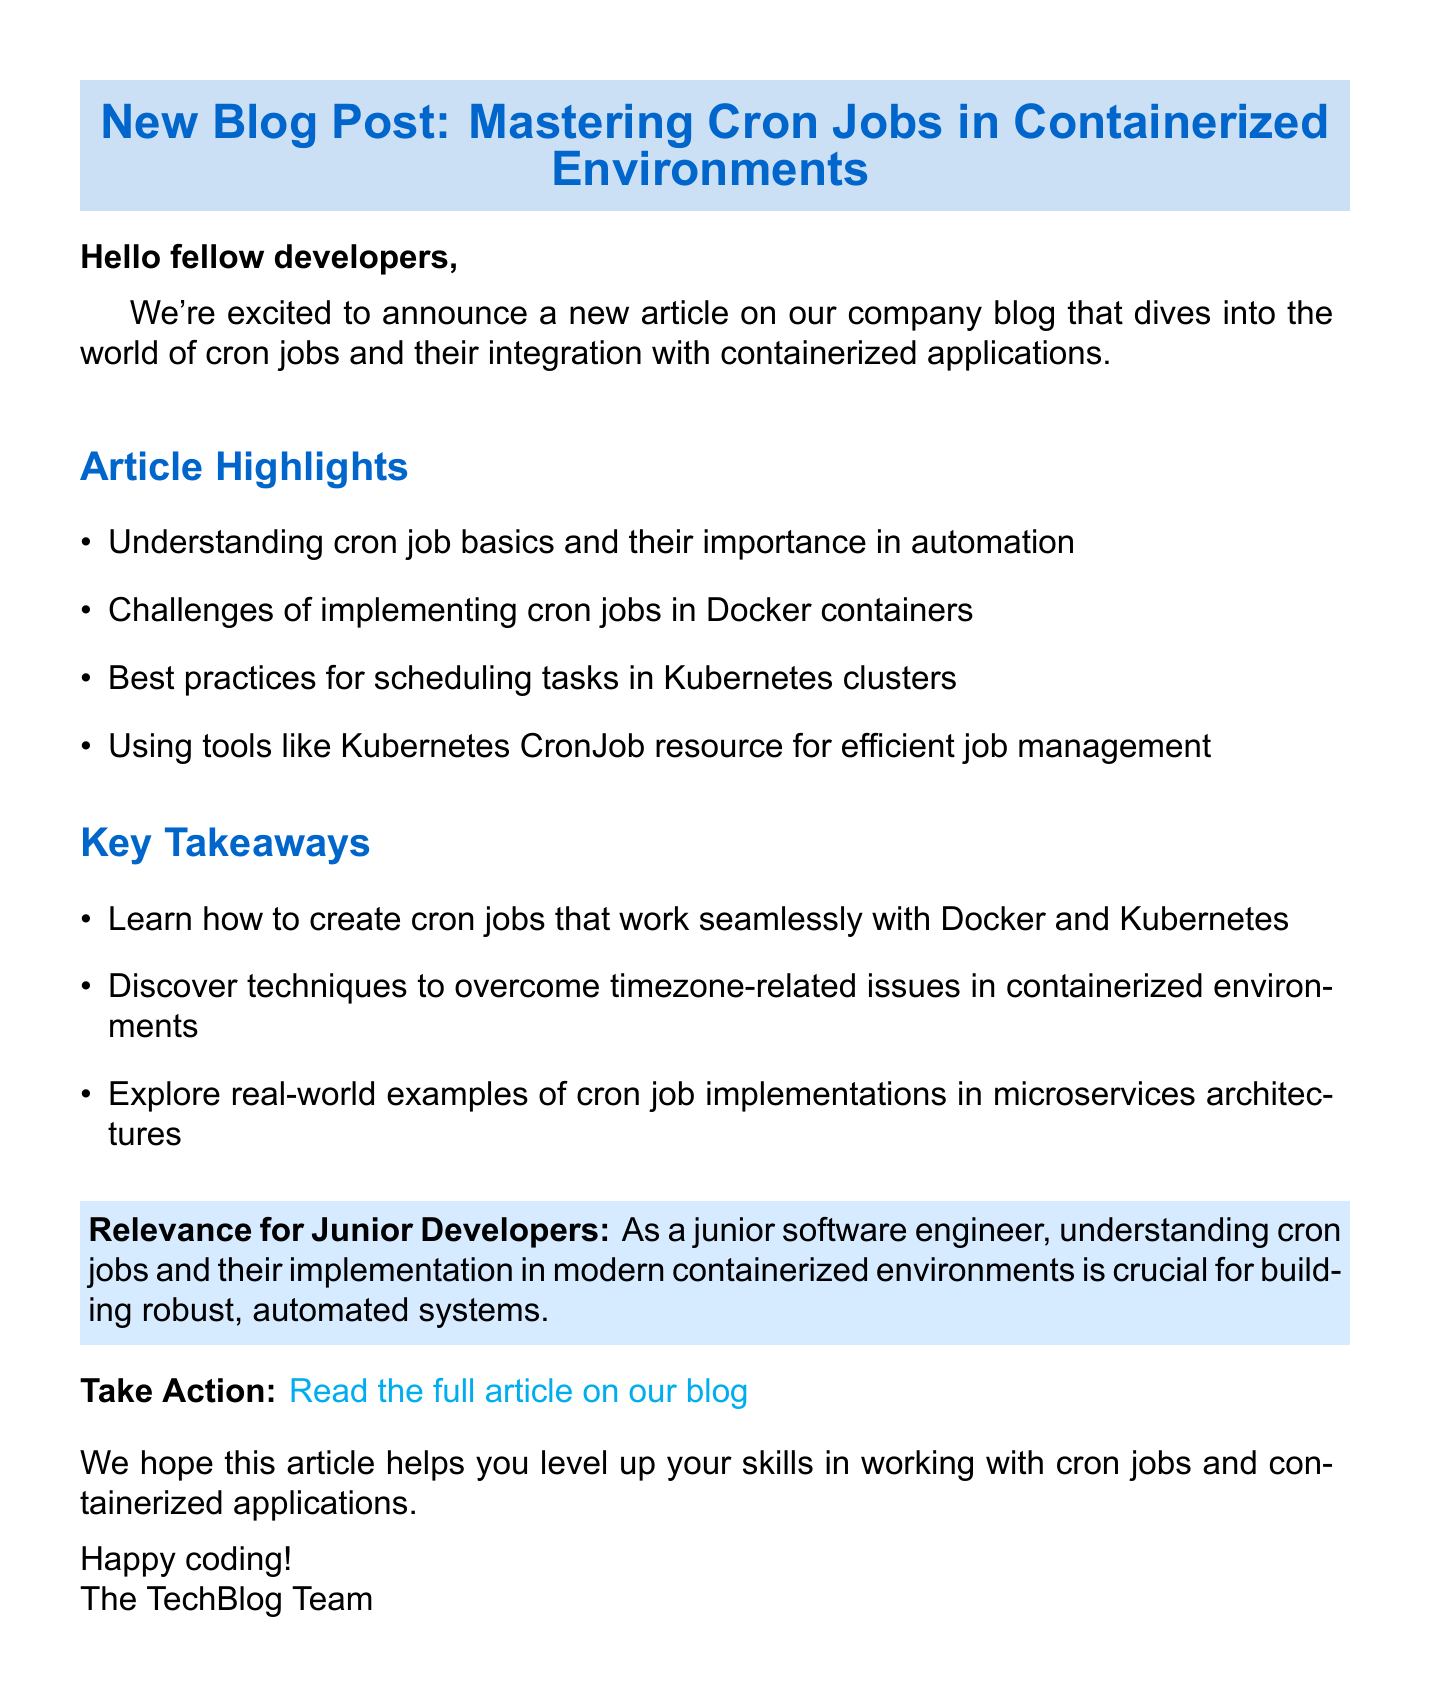What is the subject of the email? The subject is mentioned at the beginning of the document.
Answer: New Blog Post: Mastering Cron Jobs in Containerized Environments Who is the audience of the email? The greeting and content indicate that the email is directed towards a specific group.
Answer: Fellow developers What are the two main topics discussed in the article? The article highlights various topics, and two can be extracted from the list of highlights.
Answer: Cron jobs and containerized applications What is one tool mentioned for job management? The article highlights tools used for managing jobs in containerized environments.
Answer: Kubernetes CronJob resource What is a key takeaway related to timezone issues? The key takeaways note specific challenges associated with cron jobs.
Answer: Techniques to overcome timezone-related issues Why is this article relevant for junior developers? The relevance section explains why understanding the topic is essential for this group.
Answer: Building robust, automated systems What should readers do after reading the email? The call to action instructs users on the next step after reading the email.
Answer: Read the full article on our blog Who signed off the email? The closing provides information about the team that wrote the email.
Answer: The TechBlog Team 